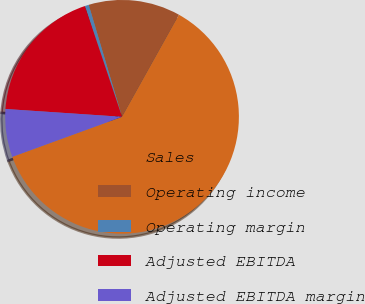<chart> <loc_0><loc_0><loc_500><loc_500><pie_chart><fcel>Sales<fcel>Operating income<fcel>Operating margin<fcel>Adjusted EBITDA<fcel>Adjusted EBITDA margin<nl><fcel>61.34%<fcel>12.7%<fcel>0.55%<fcel>18.78%<fcel>6.63%<nl></chart> 